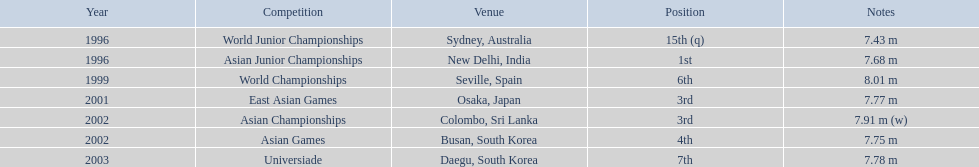In what year was the position of 3rd first achieved? 2001. 